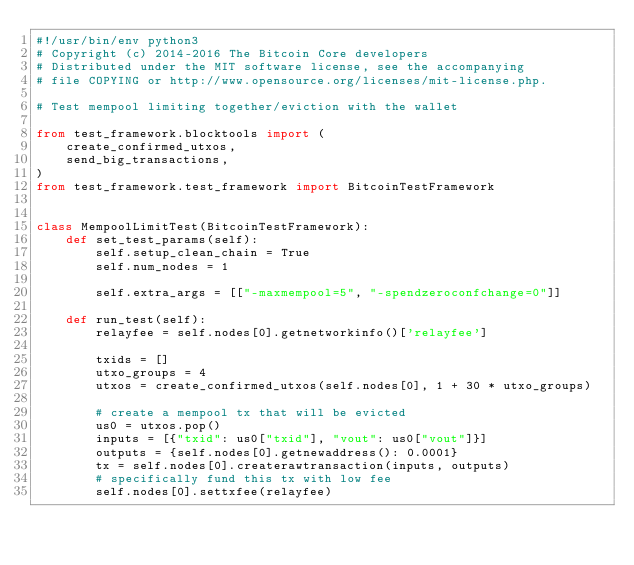<code> <loc_0><loc_0><loc_500><loc_500><_Python_>#!/usr/bin/env python3
# Copyright (c) 2014-2016 The Bitcoin Core developers
# Distributed under the MIT software license, see the accompanying
# file COPYING or http://www.opensource.org/licenses/mit-license.php.

# Test mempool limiting together/eviction with the wallet

from test_framework.blocktools import (
    create_confirmed_utxos,
    send_big_transactions,
)
from test_framework.test_framework import BitcoinTestFramework


class MempoolLimitTest(BitcoinTestFramework):
    def set_test_params(self):
        self.setup_clean_chain = True
        self.num_nodes = 1

        self.extra_args = [["-maxmempool=5", "-spendzeroconfchange=0"]]

    def run_test(self):
        relayfee = self.nodes[0].getnetworkinfo()['relayfee']

        txids = []
        utxo_groups = 4
        utxos = create_confirmed_utxos(self.nodes[0], 1 + 30 * utxo_groups)

        # create a mempool tx that will be evicted
        us0 = utxos.pop()
        inputs = [{"txid": us0["txid"], "vout": us0["vout"]}]
        outputs = {self.nodes[0].getnewaddress(): 0.0001}
        tx = self.nodes[0].createrawtransaction(inputs, outputs)
        # specifically fund this tx with low fee
        self.nodes[0].settxfee(relayfee)</code> 